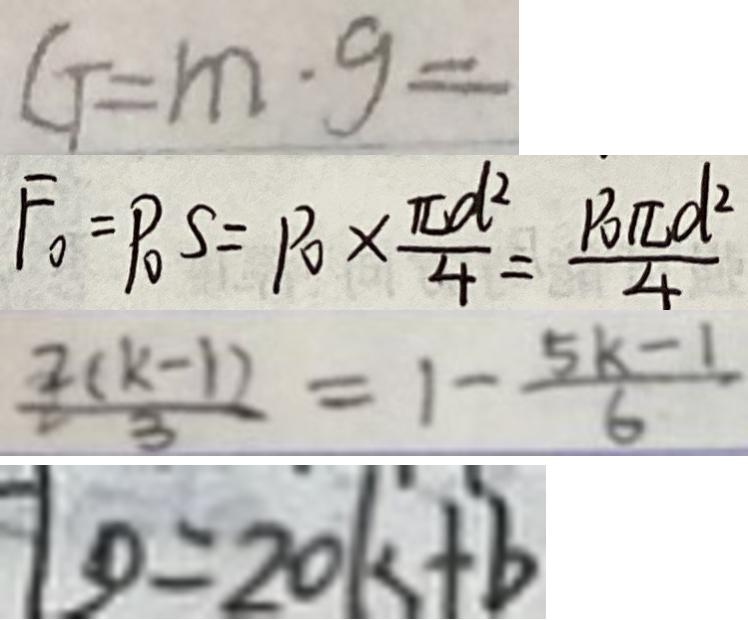Convert formula to latex. <formula><loc_0><loc_0><loc_500><loc_500>G = m \cdot g = 
 F _ { 0 } = P _ { 0 } S = P _ { 0 } \times \frac { \pi d ^ { 2 } } { 4 } = \frac { P _ { 0 } \pi d ^ { 2 } } { 4 } 
 \frac { 2 ( k - 1 ) } { 3 } = 1 - \frac { 5 k - 1 } { 6 } 
 1 0 = 2 0 k + b</formula> 